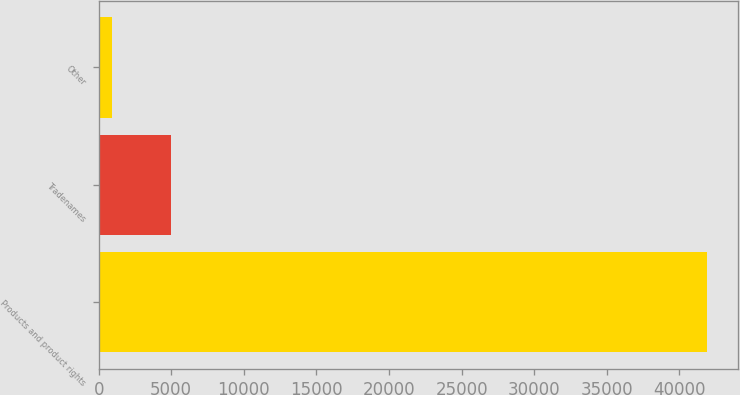Convert chart to OTSL. <chart><loc_0><loc_0><loc_500><loc_500><bar_chart><fcel>Products and product rights<fcel>Tradenames<fcel>Other<nl><fcel>41932<fcel>4999.6<fcel>896<nl></chart> 